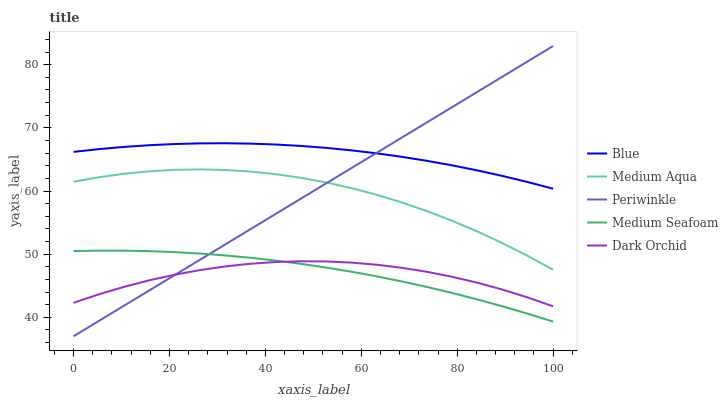Does Dark Orchid have the minimum area under the curve?
Answer yes or no. Yes. Does Blue have the maximum area under the curve?
Answer yes or no. Yes. Does Periwinkle have the minimum area under the curve?
Answer yes or no. No. Does Periwinkle have the maximum area under the curve?
Answer yes or no. No. Is Periwinkle the smoothest?
Answer yes or no. Yes. Is Medium Aqua the roughest?
Answer yes or no. Yes. Is Medium Aqua the smoothest?
Answer yes or no. No. Is Periwinkle the roughest?
Answer yes or no. No. Does Periwinkle have the lowest value?
Answer yes or no. Yes. Does Medium Aqua have the lowest value?
Answer yes or no. No. Does Periwinkle have the highest value?
Answer yes or no. Yes. Does Medium Aqua have the highest value?
Answer yes or no. No. Is Medium Seafoam less than Medium Aqua?
Answer yes or no. Yes. Is Blue greater than Medium Aqua?
Answer yes or no. Yes. Does Dark Orchid intersect Medium Seafoam?
Answer yes or no. Yes. Is Dark Orchid less than Medium Seafoam?
Answer yes or no. No. Is Dark Orchid greater than Medium Seafoam?
Answer yes or no. No. Does Medium Seafoam intersect Medium Aqua?
Answer yes or no. No. 